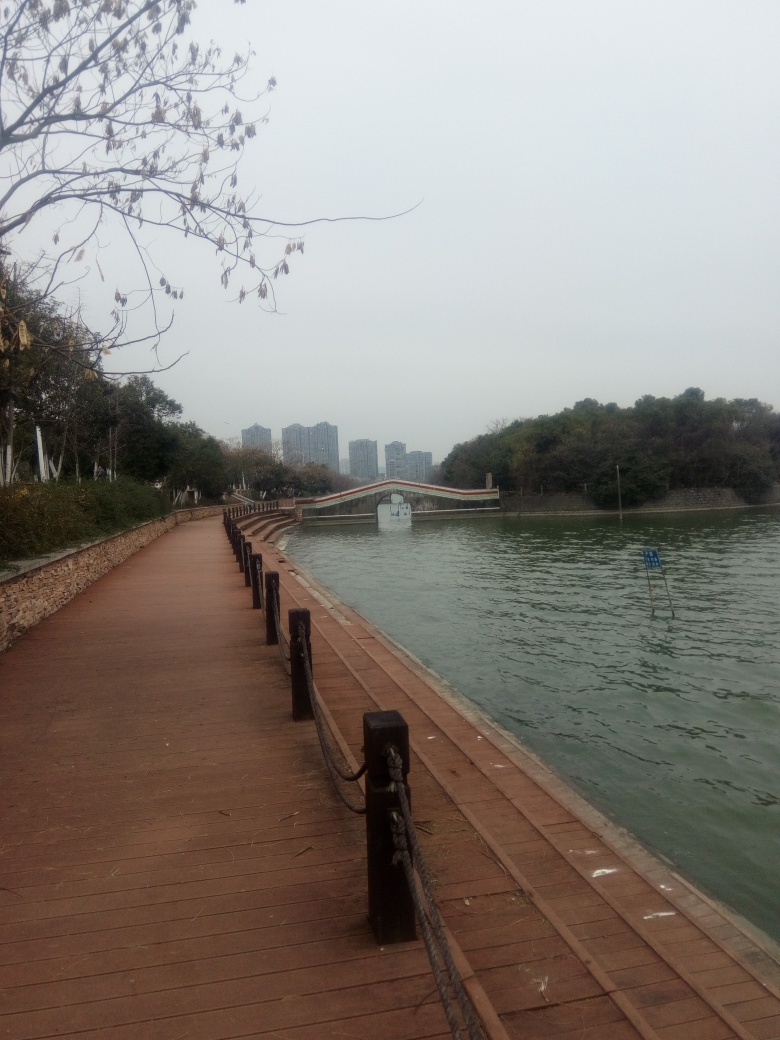How is the lighting in the image?
A. excessive
B. overexposed
C. sufficient
D. dim The lighting in the image could be best described as sufficient. It's neither excessively bright nor overexposed, allowing for clear visibility and detail throughout the scene. However, while there is an overall balance in the exposure, the lighting does not give an impression of vibrancy or strong contrast as it may appear a bit flat, possibly due to an overcast sky, which technically could lead one to think of it as somewhat on the dimmer side. Overall, the answer 'sufficient' aptly describes the light level, but considering the nuance of the scenery could introduce a subjective preference for it to be slightly brighter. 